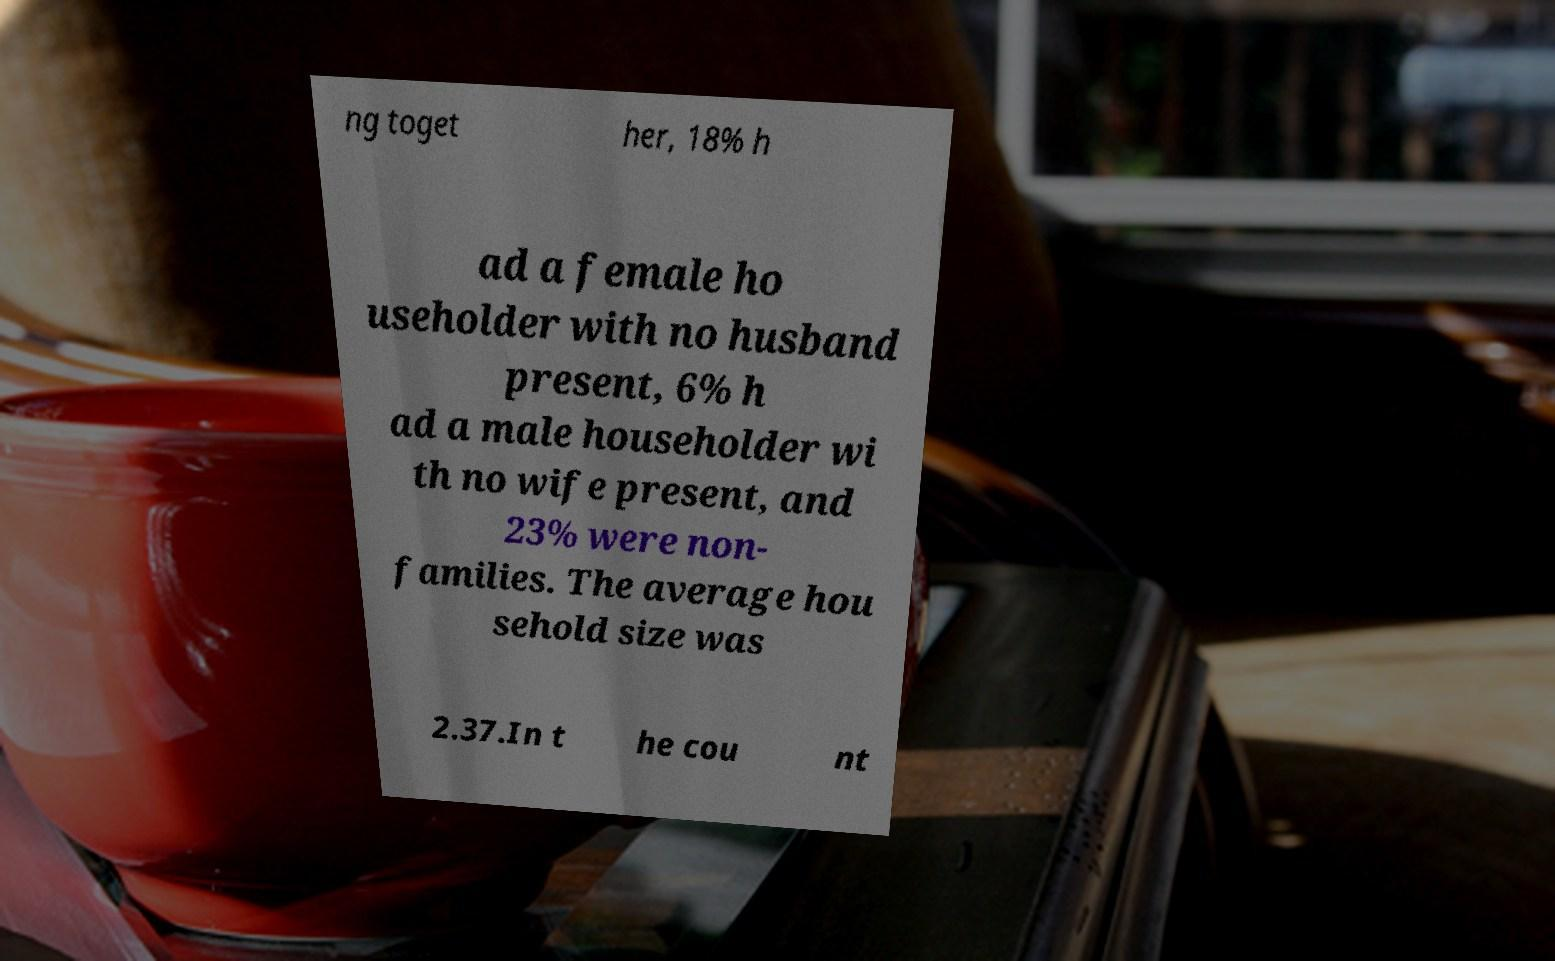Can you accurately transcribe the text from the provided image for me? ng toget her, 18% h ad a female ho useholder with no husband present, 6% h ad a male householder wi th no wife present, and 23% were non- families. The average hou sehold size was 2.37.In t he cou nt 